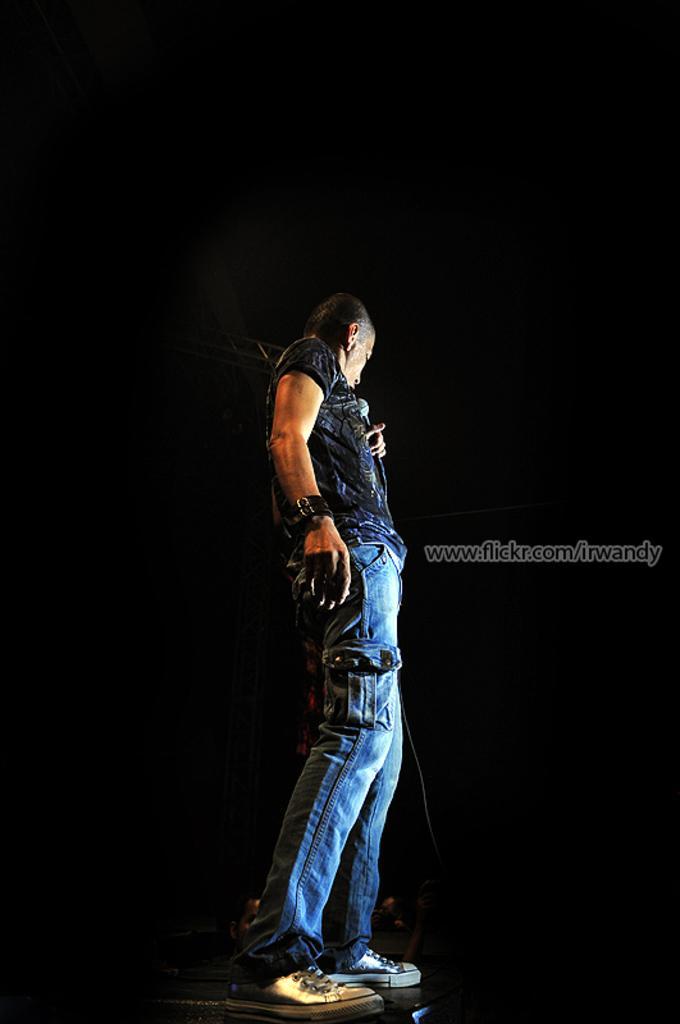Please provide a concise description of this image. In this image we can see a person holding microphone in his hand is standing on the floor. In the background, we can see a metal frame. On the right side of the image we can see the text. 